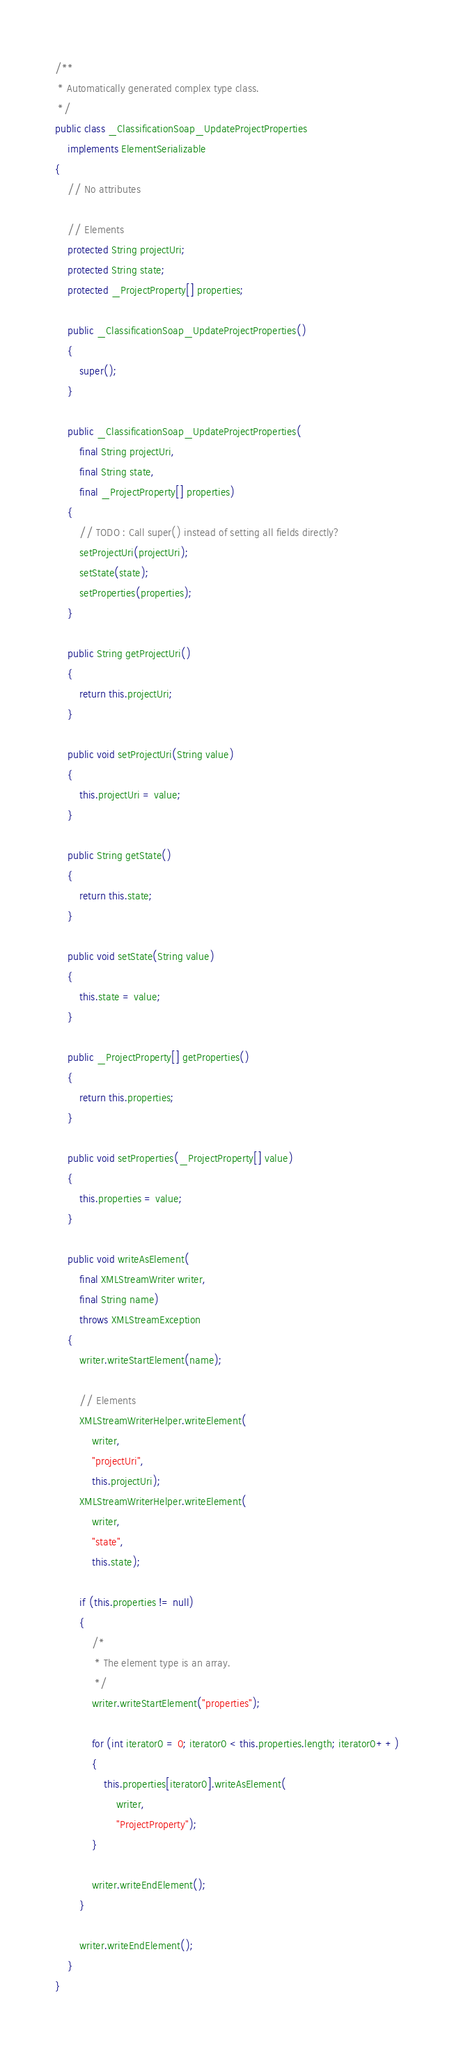<code> <loc_0><loc_0><loc_500><loc_500><_Java_>/**
 * Automatically generated complex type class.
 */
public class _ClassificationSoap_UpdateProjectProperties
    implements ElementSerializable
{
    // No attributes    

    // Elements
    protected String projectUri;
    protected String state;
    protected _ProjectProperty[] properties;

    public _ClassificationSoap_UpdateProjectProperties()
    {
        super();
    }

    public _ClassificationSoap_UpdateProjectProperties(
        final String projectUri,
        final String state,
        final _ProjectProperty[] properties)
    {
        // TODO : Call super() instead of setting all fields directly?
        setProjectUri(projectUri);
        setState(state);
        setProperties(properties);
    }

    public String getProjectUri()
    {
        return this.projectUri;
    }

    public void setProjectUri(String value)
    {
        this.projectUri = value;
    }

    public String getState()
    {
        return this.state;
    }

    public void setState(String value)
    {
        this.state = value;
    }

    public _ProjectProperty[] getProperties()
    {
        return this.properties;
    }

    public void setProperties(_ProjectProperty[] value)
    {
        this.properties = value;
    }

    public void writeAsElement(
        final XMLStreamWriter writer,
        final String name)
        throws XMLStreamException
    {
        writer.writeStartElement(name);

        // Elements
        XMLStreamWriterHelper.writeElement(
            writer,
            "projectUri",
            this.projectUri);
        XMLStreamWriterHelper.writeElement(
            writer,
            "state",
            this.state);

        if (this.properties != null)
        {
            /*
             * The element type is an array.
             */
            writer.writeStartElement("properties");

            for (int iterator0 = 0; iterator0 < this.properties.length; iterator0++)
            {
                this.properties[iterator0].writeAsElement(
                    writer,
                    "ProjectProperty");
            }

            writer.writeEndElement();
        }

        writer.writeEndElement();
    }
}
</code> 